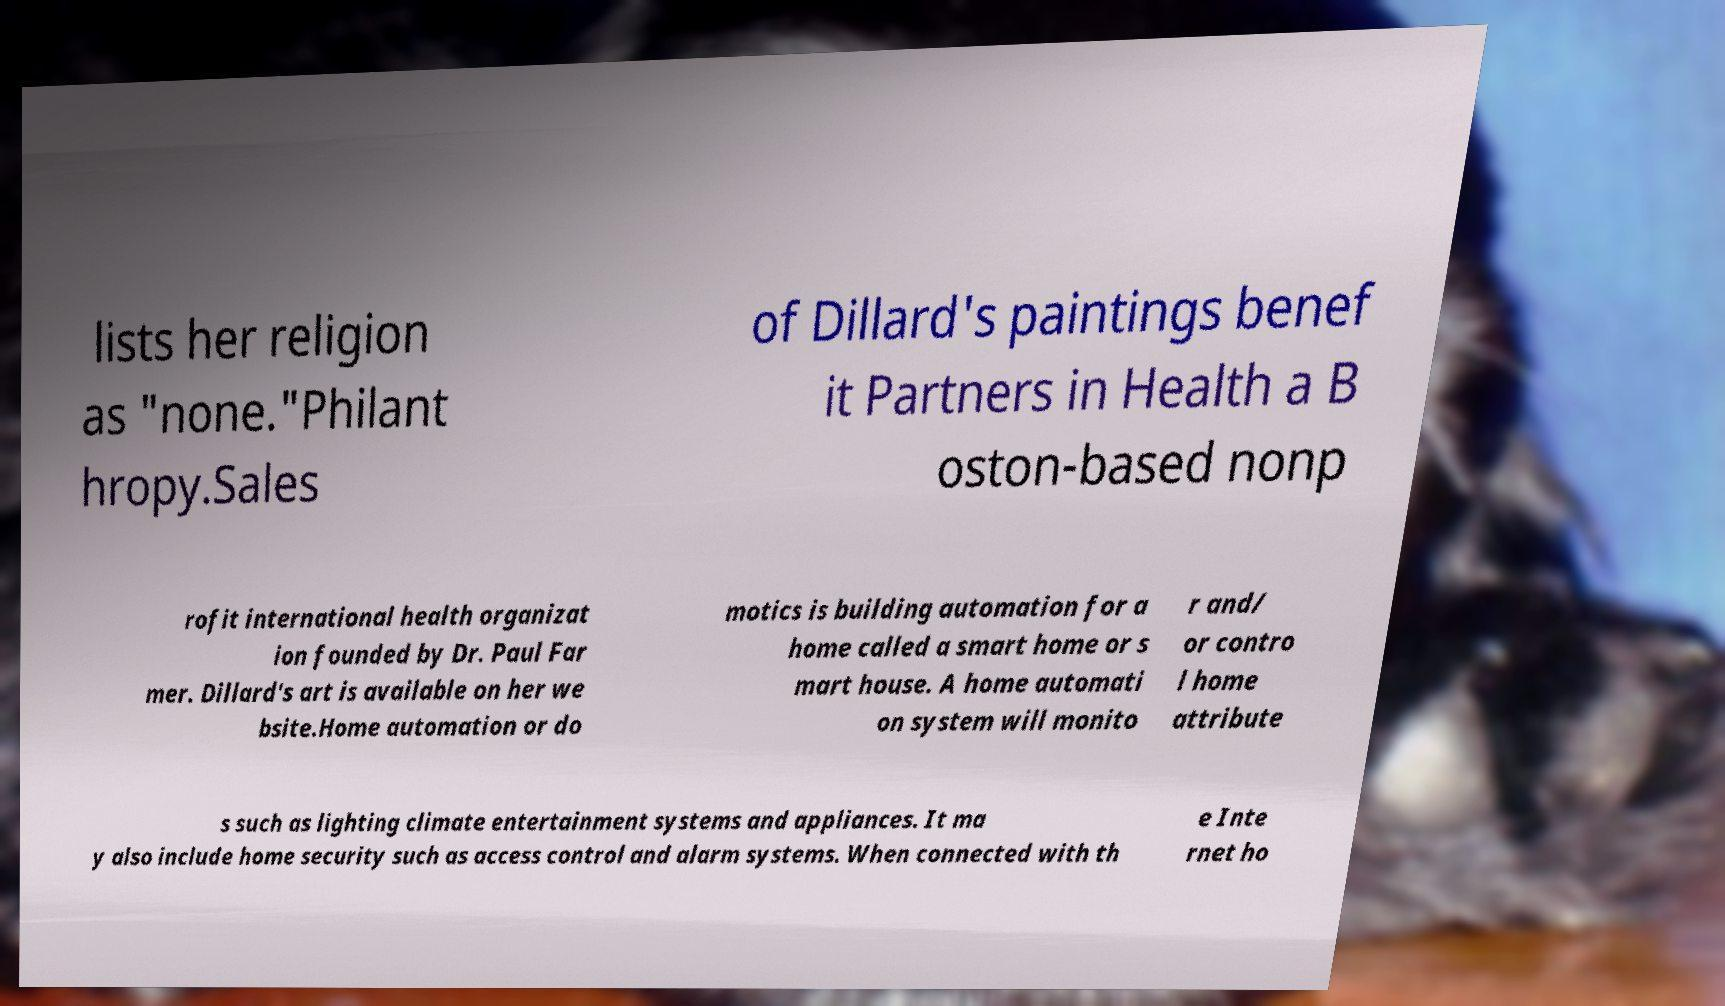There's text embedded in this image that I need extracted. Can you transcribe it verbatim? lists her religion as "none."Philant hropy.Sales of Dillard's paintings benef it Partners in Health a B oston-based nonp rofit international health organizat ion founded by Dr. Paul Far mer. Dillard's art is available on her we bsite.Home automation or do motics is building automation for a home called a smart home or s mart house. A home automati on system will monito r and/ or contro l home attribute s such as lighting climate entertainment systems and appliances. It ma y also include home security such as access control and alarm systems. When connected with th e Inte rnet ho 